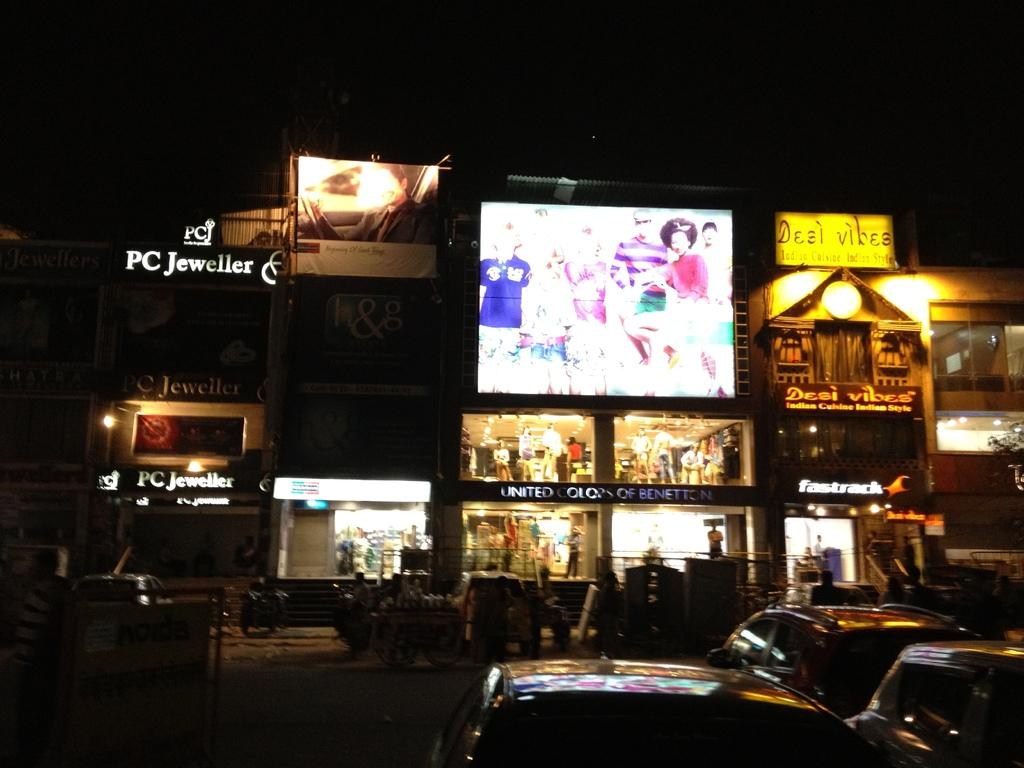<image>
Offer a succinct explanation of the picture presented. A store named Desi Vibes has a yellow sign. 